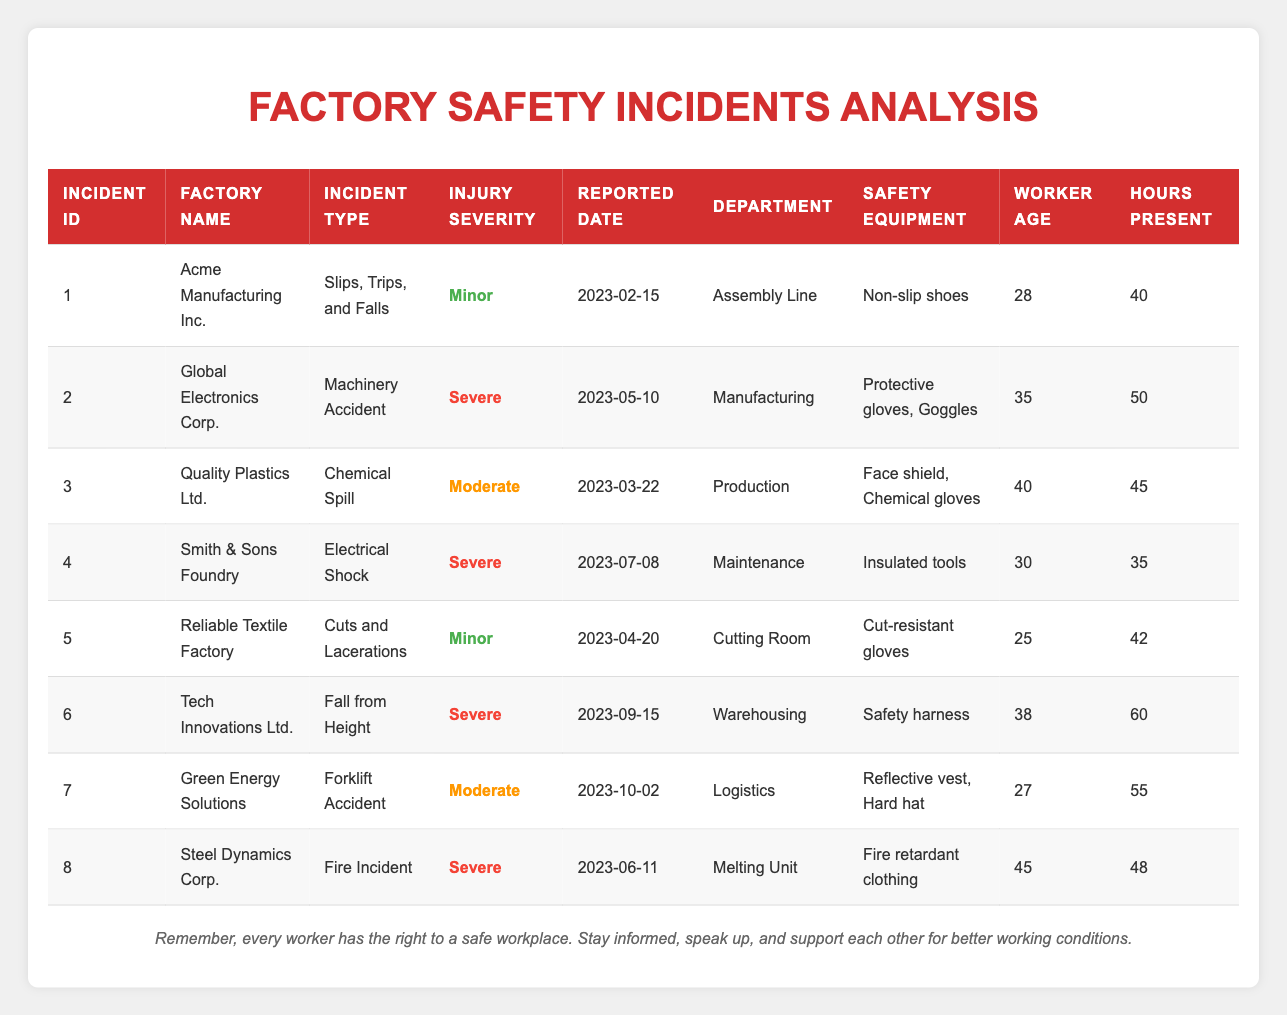What is the injury severity of the incident reported by Acme Manufacturing Inc.? The table shows the specific row for Acme Manufacturing Inc., which provides details about their incident. The "Injury Severity" column indicates that it is "Minor."
Answer: Minor How many incidents involved severe injuries? By examining the "Injury Severity" column, we can count the instances labeled as "Severe." There are four incidents: those from Global Electronics Corp., Smith & Sons Foundry, Tech Innovations Ltd., and Steel Dynamics Corp.
Answer: 4 Which factory had the highest hours worked by workers during an incident? Looking through the "Hours Present" column, the highest value found is 60, reported by Tech Innovations Ltd. for the incident of "Fall from Height."
Answer: Tech Innovations Ltd What incident type is associated with 40-year-old workers? From the table, we identify that the incident "Chemical Spill" from Quality Plastics Ltd. is associated with a 40-year-old worker.
Answer: Chemical Spill Was there an incident involving a chemical spill? Scanning through the "Incident Type" column, "Chemical Spill" is present in the row related to Quality Plastics Ltd. Therefore, the answer is yes.
Answer: Yes What is the average age of workers involved in incidents classified as severe? The incidents classified as severe include those from Global Electronics Corp. (35), Smith & Sons Foundry (30), Tech Innovations Ltd. (38), and Steel Dynamics Corp. (45). Their ages sum up to 148, and dividing by 4 gives an average age of 37.
Answer: 37 Which incident involved the use of a safety harness? Referring to the table, we find that the incident labeled "Fall from Height" at Tech Innovations Ltd. involved the worker using a safety harness.
Answer: Fall from Height Did any incident occur in the assembly line department? The table indicates that there is indeed an incident from Acme Manufacturing Inc. that occurred in the "Assembly Line" department, confirming the answer as yes.
Answer: Yes List all the factories that reported minor injuries. By reviewing the "Injury Severity" column, we find minor injuries reported by Acme Manufacturing Inc. and Reliable Textile Factory. The factories are therefore Acme Manufacturing Inc. and Reliable Textile Factory.
Answer: Acme Manufacturing Inc., Reliable Textile Factory What incident had the longest time of 60 hours present and what was the injury severity? From the row for Tech Innovations Ltd., we see that the incident "Fall from Height" had 60 hours present and the injury severity was classified as "Severe."
Answer: Fall from Height, Severe 